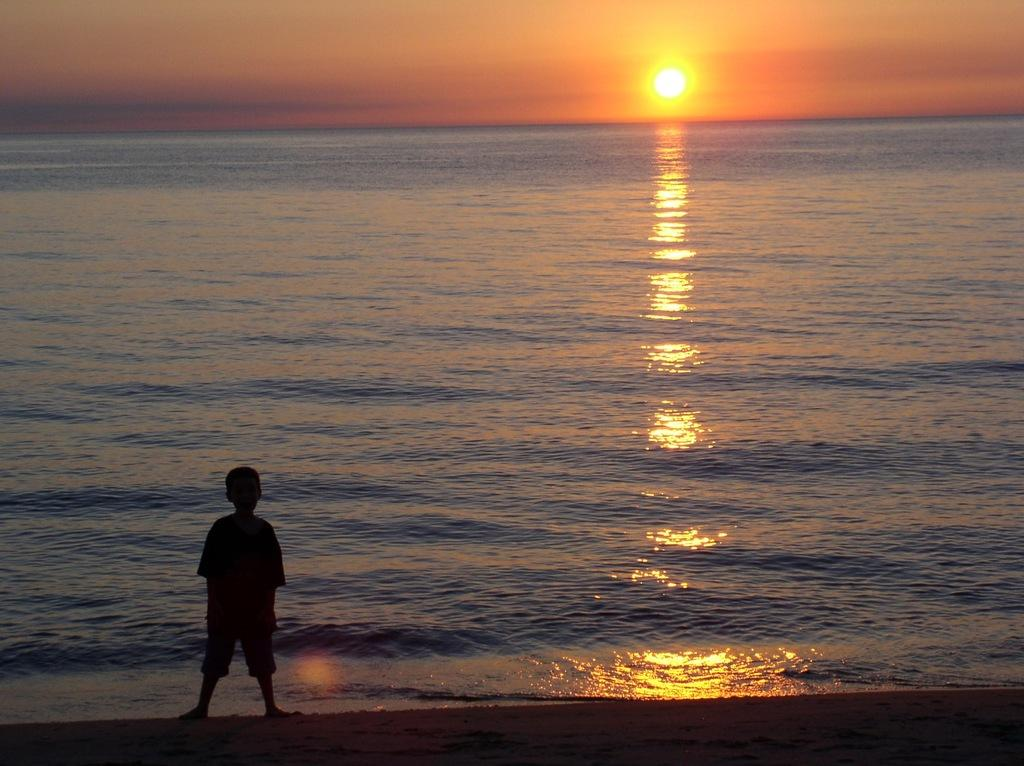What is the kid doing in the image? The kid is standing on the ground in the image. Where is the kid located in relation to water? The kid is near water in the image. What can be seen in the sky in the image? There is sun visible in the sky, and there are clouds as well. What part of the advice can be seen in the image? There is no advice present in the image, so it cannot be seen. 